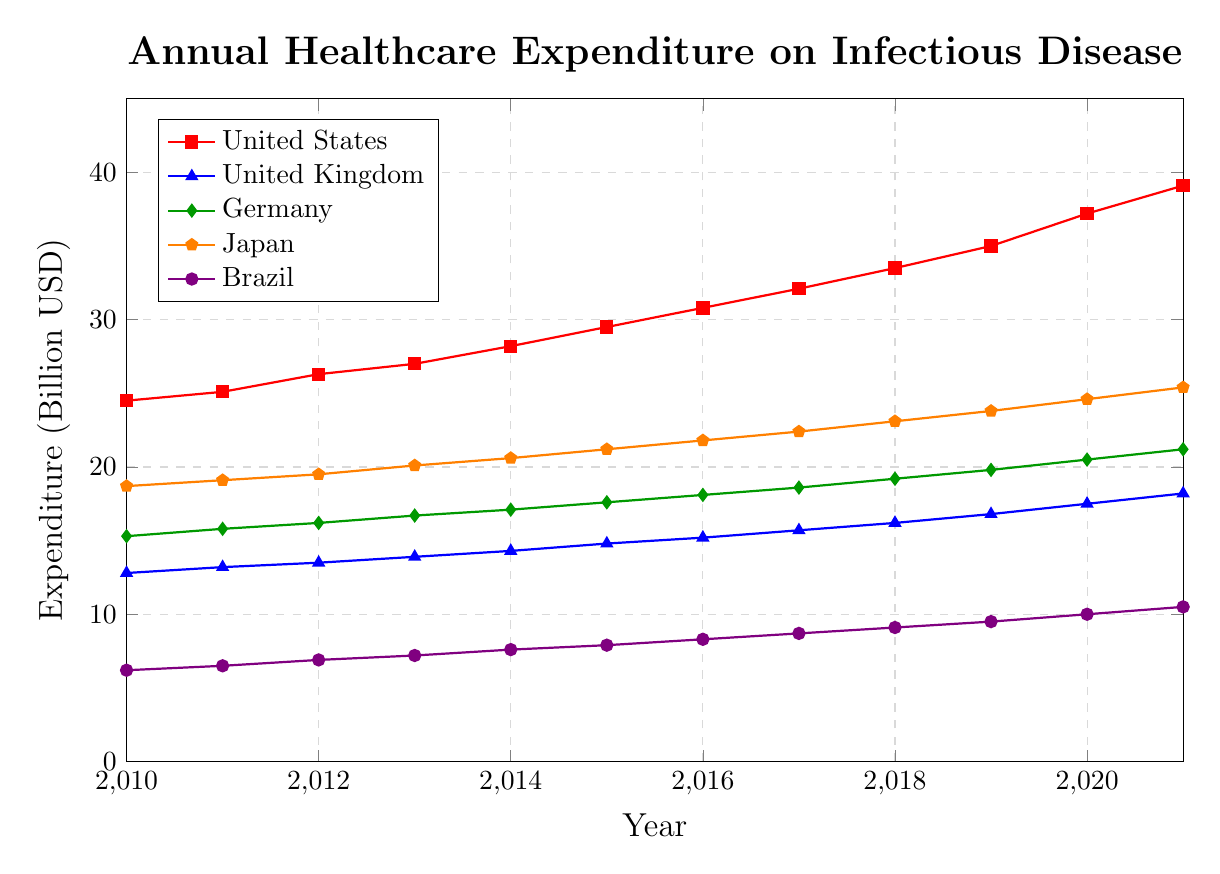Which country had the highest healthcare expenditure for infectious disease prevention and treatment in 2021? By locating the highest point in 2021 in the graph, we can see that the United States has the highest line above all other countries.
Answer: United States How many countries had an expenditure greater than 20 billion USD in 2020? By examining the height and labels of the lines for the year 2020, we notice that the expenditures for the United States, Germany, and Japan are all above 20 billion USD.
Answer: Three What is the average annual increase in expenditure for the United Kingdom from 2010 to 2021? To determine the average increase, calculate the expenditure difference from 2010 to 2021 (18.2 - 12.8 = 5.4) and then divide by the number of years (5.4 / 11 ≈ 0.49).
Answer: 0.49 billion USD Which country had the smallest increase in healthcare expenditure from 2010 to 2021? By assessing the difference between the expenditures for each country in 2010 and 2021, Brazil's increase (10.5 - 6.2 = 4.3) is the smallest compared to the others.
Answer: Brazil In what year did Japan's expenditure surpass 20 billion USD? By following Japan's line, which is marked with orange pentagons, we see that the expenditure surpasses 20 billion USD in the year 2015.
Answer: 2015 Compare the expenditures between Germany and Japan in 2017. Which was higher and by how much? Locate the points for Germany and Japan in 2017. Germany (18.6) has a lower expenditure compared to Japan (22.4). The difference is 22.4 - 18.6 = 3.8 billion USD.
Answer: Japan, by 3.8 billion USD What is the total expenditure of Brazil from 2010 to 2021? Sum the yearly expenditures for Brazil: 6.2 + 6.5 + 6.9 + 7.2 + 7.6 + 7.9 + 8.3 + 8.7 + 9.1 + 9.5 + 10.0 + 10.5 = 98.4 billion USD.
Answer: 98.4 billion USD In the year 2015, rank the countries based on their healthcare expenditure from highest to lowest. By identifying each country's expenditure in 2015, the ranking is United States (29.5), Japan (21.2), Germany (17.6), United Kingdom (14.8), Brazil (7.9).
Answer: United States, Japan, Germany, United Kingdom, Brazil Which country shows the least variability in its annual expenditure growth from 2010 to 2021? By observing the slopes and smoothness of the lines, the United Kingdom has a relatively steady and smallest slope, implying the least variability.
Answer: United Kingdom 